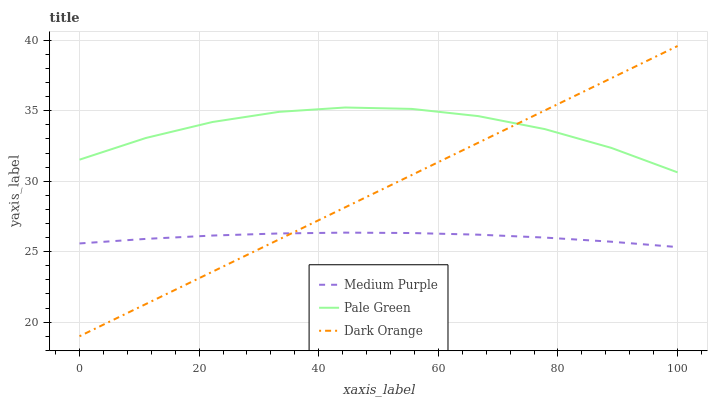Does Dark Orange have the minimum area under the curve?
Answer yes or no. No. Does Dark Orange have the maximum area under the curve?
Answer yes or no. No. Is Pale Green the smoothest?
Answer yes or no. No. Is Dark Orange the roughest?
Answer yes or no. No. Does Pale Green have the lowest value?
Answer yes or no. No. Does Pale Green have the highest value?
Answer yes or no. No. Is Medium Purple less than Pale Green?
Answer yes or no. Yes. Is Pale Green greater than Medium Purple?
Answer yes or no. Yes. Does Medium Purple intersect Pale Green?
Answer yes or no. No. 